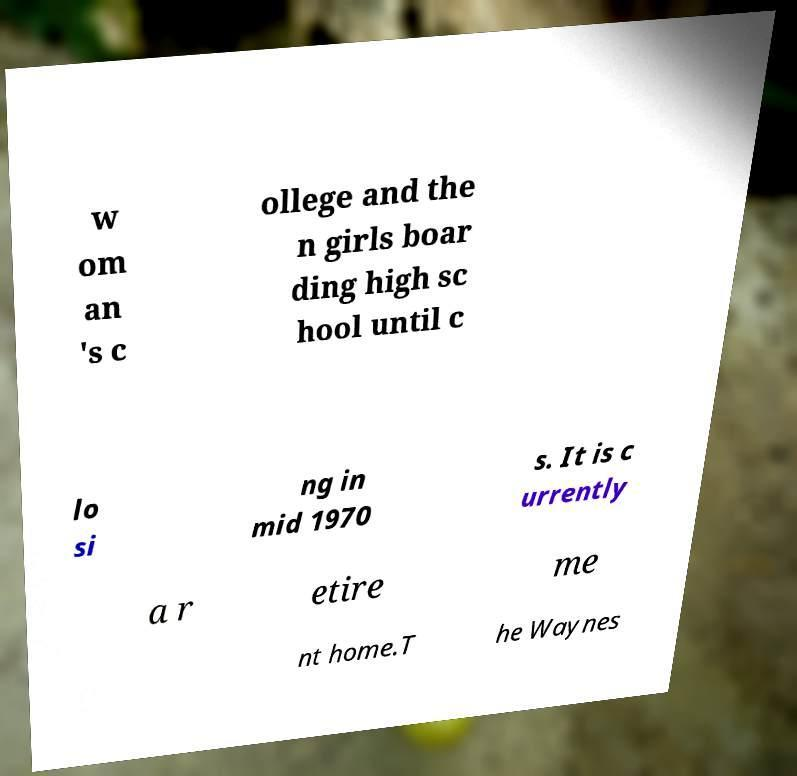Could you assist in decoding the text presented in this image and type it out clearly? w om an 's c ollege and the n girls boar ding high sc hool until c lo si ng in mid 1970 s. It is c urrently a r etire me nt home.T he Waynes 